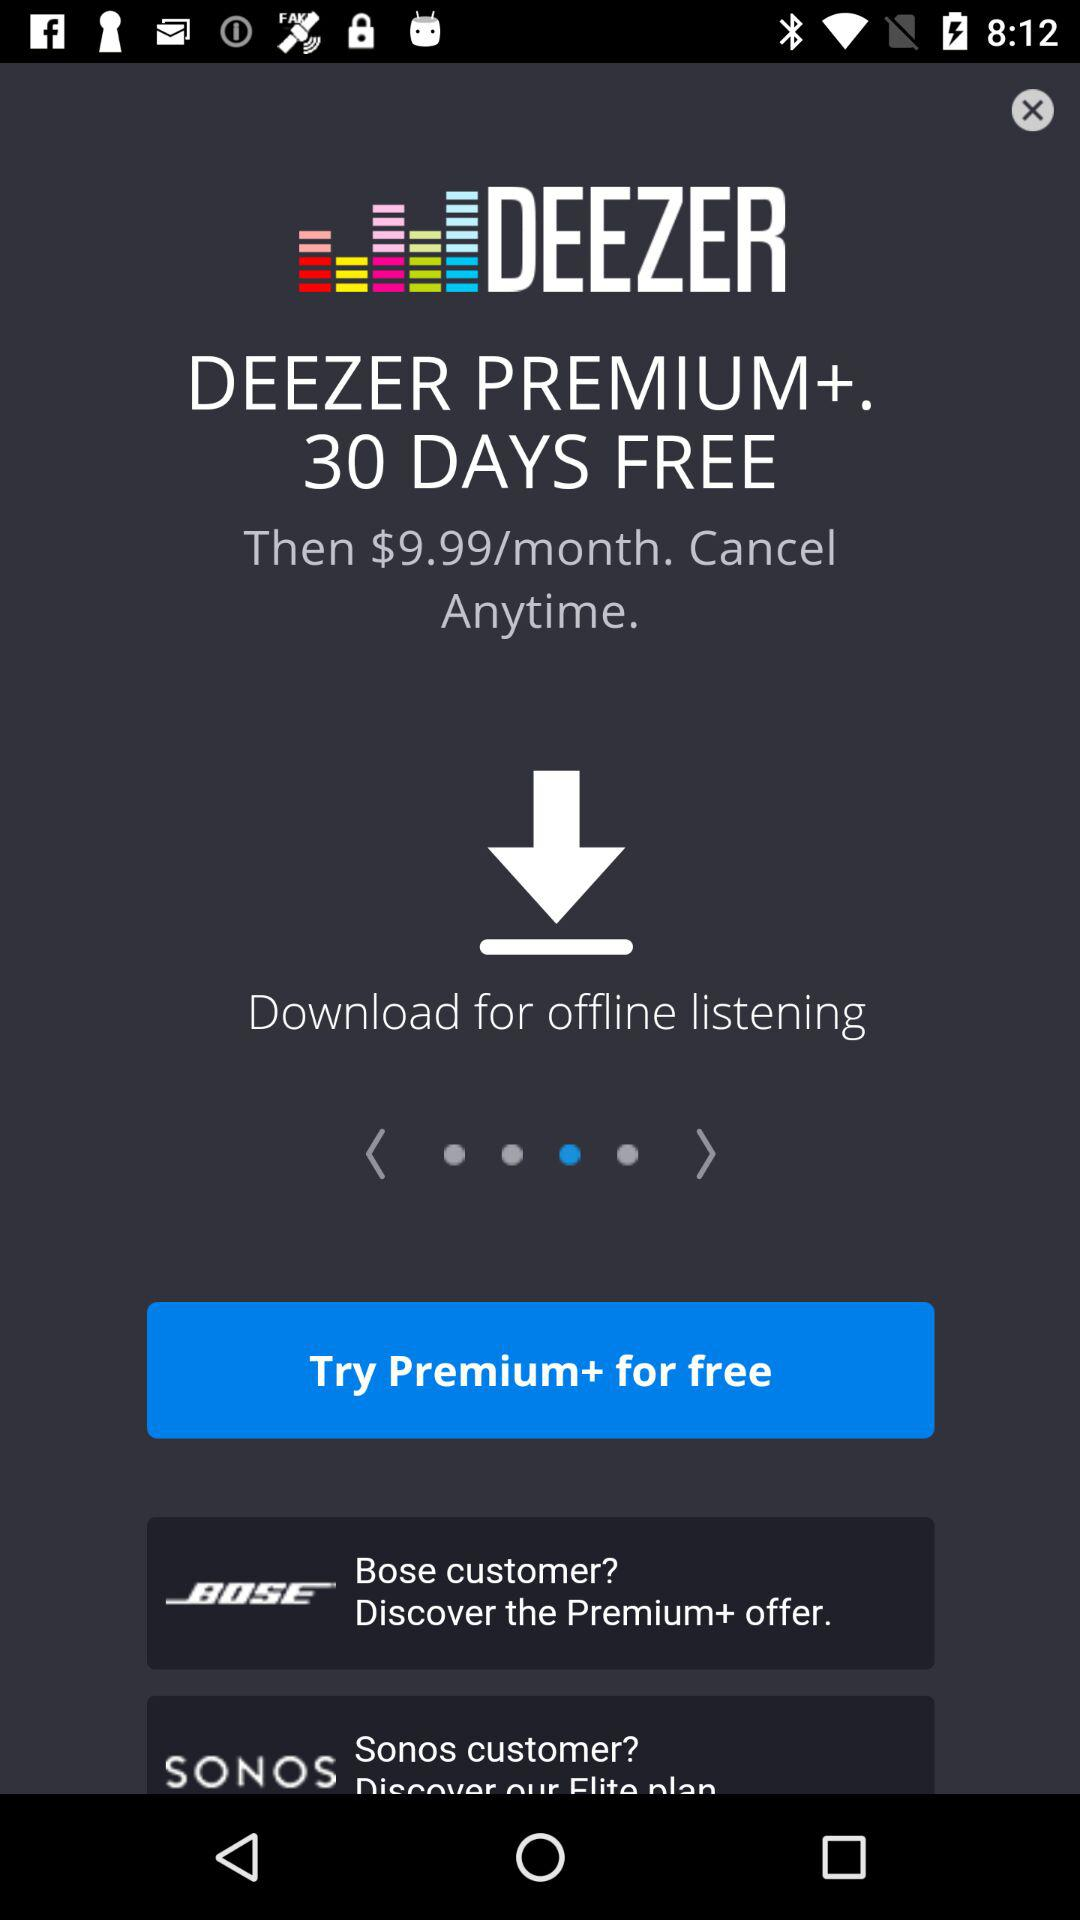What is the monthly subscription price of the "DEEZER PREMIUM+" plan? The monthly subscription price of the "DEEZER PREMIUM+" plan is $9.99. 